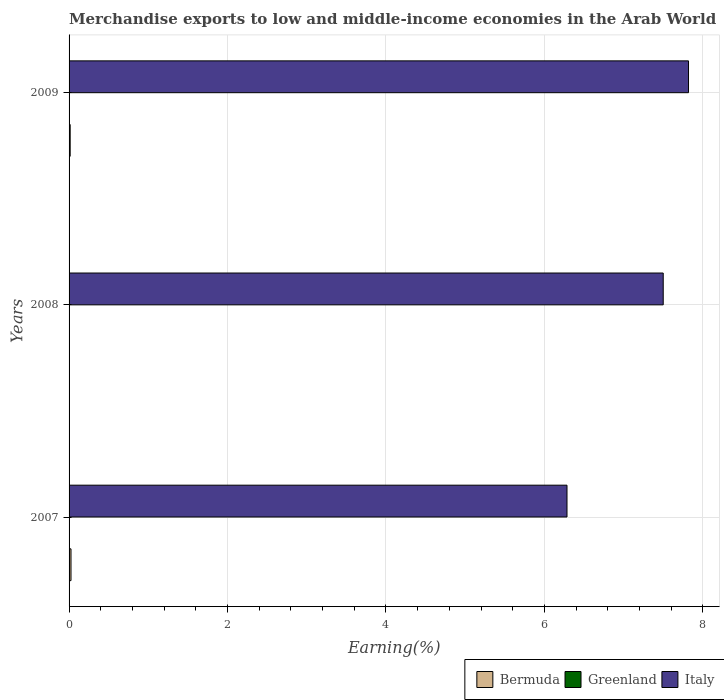How many different coloured bars are there?
Your answer should be very brief. 3. How many bars are there on the 3rd tick from the bottom?
Your answer should be compact. 3. What is the percentage of amount earned from merchandise exports in Bermuda in 2008?
Keep it short and to the point. 0. Across all years, what is the maximum percentage of amount earned from merchandise exports in Italy?
Your answer should be very brief. 7.82. Across all years, what is the minimum percentage of amount earned from merchandise exports in Bermuda?
Offer a very short reply. 0. In which year was the percentage of amount earned from merchandise exports in Bermuda maximum?
Your response must be concise. 2007. What is the total percentage of amount earned from merchandise exports in Greenland in the graph?
Make the answer very short. 0. What is the difference between the percentage of amount earned from merchandise exports in Italy in 2007 and that in 2008?
Make the answer very short. -1.21. What is the difference between the percentage of amount earned from merchandise exports in Greenland in 2009 and the percentage of amount earned from merchandise exports in Bermuda in 2008?
Your response must be concise. -0. What is the average percentage of amount earned from merchandise exports in Bermuda per year?
Offer a terse response. 0.01. In the year 2009, what is the difference between the percentage of amount earned from merchandise exports in Italy and percentage of amount earned from merchandise exports in Bermuda?
Give a very brief answer. 7.8. In how many years, is the percentage of amount earned from merchandise exports in Greenland greater than 3.6 %?
Your answer should be compact. 0. What is the ratio of the percentage of amount earned from merchandise exports in Greenland in 2008 to that in 2009?
Offer a terse response. 1.6. Is the difference between the percentage of amount earned from merchandise exports in Italy in 2007 and 2008 greater than the difference between the percentage of amount earned from merchandise exports in Bermuda in 2007 and 2008?
Your answer should be very brief. No. What is the difference between the highest and the second highest percentage of amount earned from merchandise exports in Greenland?
Give a very brief answer. 3.956505574129597e-5. What is the difference between the highest and the lowest percentage of amount earned from merchandise exports in Bermuda?
Make the answer very short. 0.02. In how many years, is the percentage of amount earned from merchandise exports in Italy greater than the average percentage of amount earned from merchandise exports in Italy taken over all years?
Offer a very short reply. 2. Is the sum of the percentage of amount earned from merchandise exports in Bermuda in 2008 and 2009 greater than the maximum percentage of amount earned from merchandise exports in Greenland across all years?
Provide a succinct answer. Yes. What does the 2nd bar from the top in 2007 represents?
Ensure brevity in your answer.  Greenland. What does the 3rd bar from the bottom in 2009 represents?
Make the answer very short. Italy. Is it the case that in every year, the sum of the percentage of amount earned from merchandise exports in Italy and percentage of amount earned from merchandise exports in Greenland is greater than the percentage of amount earned from merchandise exports in Bermuda?
Your answer should be compact. Yes. How many years are there in the graph?
Your response must be concise. 3. Are the values on the major ticks of X-axis written in scientific E-notation?
Provide a short and direct response. No. Does the graph contain any zero values?
Your response must be concise. No. Where does the legend appear in the graph?
Your answer should be compact. Bottom right. How many legend labels are there?
Keep it short and to the point. 3. How are the legend labels stacked?
Offer a terse response. Horizontal. What is the title of the graph?
Ensure brevity in your answer.  Merchandise exports to low and middle-income economies in the Arab World. Does "Sub-Saharan Africa (all income levels)" appear as one of the legend labels in the graph?
Your answer should be compact. No. What is the label or title of the X-axis?
Make the answer very short. Earning(%). What is the label or title of the Y-axis?
Ensure brevity in your answer.  Years. What is the Earning(%) in Bermuda in 2007?
Offer a terse response. 0.02. What is the Earning(%) in Greenland in 2007?
Offer a terse response. 0. What is the Earning(%) in Italy in 2007?
Your answer should be compact. 6.29. What is the Earning(%) of Bermuda in 2008?
Provide a short and direct response. 0. What is the Earning(%) in Greenland in 2008?
Your answer should be very brief. 0. What is the Earning(%) in Italy in 2008?
Provide a short and direct response. 7.5. What is the Earning(%) in Bermuda in 2009?
Provide a succinct answer. 0.01. What is the Earning(%) of Greenland in 2009?
Provide a succinct answer. 0. What is the Earning(%) in Italy in 2009?
Ensure brevity in your answer.  7.82. Across all years, what is the maximum Earning(%) of Bermuda?
Your answer should be very brief. 0.02. Across all years, what is the maximum Earning(%) of Greenland?
Your response must be concise. 0. Across all years, what is the maximum Earning(%) of Italy?
Your response must be concise. 7.82. Across all years, what is the minimum Earning(%) of Bermuda?
Provide a short and direct response. 0. Across all years, what is the minimum Earning(%) of Greenland?
Provide a succinct answer. 0. Across all years, what is the minimum Earning(%) in Italy?
Give a very brief answer. 6.29. What is the total Earning(%) in Bermuda in the graph?
Your answer should be very brief. 0.04. What is the total Earning(%) of Greenland in the graph?
Provide a succinct answer. 0. What is the total Earning(%) in Italy in the graph?
Give a very brief answer. 21.6. What is the difference between the Earning(%) of Greenland in 2007 and that in 2008?
Provide a succinct answer. -0. What is the difference between the Earning(%) of Italy in 2007 and that in 2008?
Your response must be concise. -1.21. What is the difference between the Earning(%) of Bermuda in 2007 and that in 2009?
Offer a very short reply. 0.01. What is the difference between the Earning(%) in Greenland in 2007 and that in 2009?
Give a very brief answer. 0. What is the difference between the Earning(%) of Italy in 2007 and that in 2009?
Provide a short and direct response. -1.53. What is the difference between the Earning(%) in Bermuda in 2008 and that in 2009?
Your answer should be very brief. -0.01. What is the difference between the Earning(%) of Italy in 2008 and that in 2009?
Provide a succinct answer. -0.32. What is the difference between the Earning(%) of Bermuda in 2007 and the Earning(%) of Greenland in 2008?
Give a very brief answer. 0.02. What is the difference between the Earning(%) in Bermuda in 2007 and the Earning(%) in Italy in 2008?
Your answer should be very brief. -7.48. What is the difference between the Earning(%) of Greenland in 2007 and the Earning(%) of Italy in 2008?
Your answer should be compact. -7.5. What is the difference between the Earning(%) of Bermuda in 2007 and the Earning(%) of Greenland in 2009?
Make the answer very short. 0.02. What is the difference between the Earning(%) of Bermuda in 2007 and the Earning(%) of Italy in 2009?
Offer a very short reply. -7.79. What is the difference between the Earning(%) in Greenland in 2007 and the Earning(%) in Italy in 2009?
Give a very brief answer. -7.82. What is the difference between the Earning(%) of Bermuda in 2008 and the Earning(%) of Greenland in 2009?
Give a very brief answer. 0. What is the difference between the Earning(%) of Bermuda in 2008 and the Earning(%) of Italy in 2009?
Keep it short and to the point. -7.81. What is the difference between the Earning(%) in Greenland in 2008 and the Earning(%) in Italy in 2009?
Offer a very short reply. -7.82. What is the average Earning(%) in Bermuda per year?
Provide a short and direct response. 0.01. What is the average Earning(%) in Greenland per year?
Give a very brief answer. 0. What is the average Earning(%) of Italy per year?
Your answer should be compact. 7.2. In the year 2007, what is the difference between the Earning(%) in Bermuda and Earning(%) in Greenland?
Ensure brevity in your answer.  0.02. In the year 2007, what is the difference between the Earning(%) of Bermuda and Earning(%) of Italy?
Give a very brief answer. -6.26. In the year 2007, what is the difference between the Earning(%) of Greenland and Earning(%) of Italy?
Your response must be concise. -6.28. In the year 2008, what is the difference between the Earning(%) in Bermuda and Earning(%) in Greenland?
Your answer should be compact. 0. In the year 2008, what is the difference between the Earning(%) of Bermuda and Earning(%) of Italy?
Keep it short and to the point. -7.5. In the year 2008, what is the difference between the Earning(%) in Greenland and Earning(%) in Italy?
Your response must be concise. -7.5. In the year 2009, what is the difference between the Earning(%) of Bermuda and Earning(%) of Greenland?
Offer a terse response. 0.01. In the year 2009, what is the difference between the Earning(%) of Bermuda and Earning(%) of Italy?
Provide a short and direct response. -7.8. In the year 2009, what is the difference between the Earning(%) of Greenland and Earning(%) of Italy?
Your response must be concise. -7.82. What is the ratio of the Earning(%) in Bermuda in 2007 to that in 2008?
Provide a succinct answer. 5.64. What is the ratio of the Earning(%) of Greenland in 2007 to that in 2008?
Keep it short and to the point. 0.84. What is the ratio of the Earning(%) of Italy in 2007 to that in 2008?
Provide a succinct answer. 0.84. What is the ratio of the Earning(%) in Bermuda in 2007 to that in 2009?
Keep it short and to the point. 1.73. What is the ratio of the Earning(%) of Greenland in 2007 to that in 2009?
Keep it short and to the point. 1.35. What is the ratio of the Earning(%) of Italy in 2007 to that in 2009?
Ensure brevity in your answer.  0.8. What is the ratio of the Earning(%) in Bermuda in 2008 to that in 2009?
Give a very brief answer. 0.31. What is the ratio of the Earning(%) of Greenland in 2008 to that in 2009?
Your response must be concise. 1.6. What is the ratio of the Earning(%) in Italy in 2008 to that in 2009?
Your answer should be compact. 0.96. What is the difference between the highest and the second highest Earning(%) of Bermuda?
Give a very brief answer. 0.01. What is the difference between the highest and the second highest Earning(%) in Greenland?
Offer a very short reply. 0. What is the difference between the highest and the second highest Earning(%) of Italy?
Offer a very short reply. 0.32. What is the difference between the highest and the lowest Earning(%) of Italy?
Your response must be concise. 1.53. 